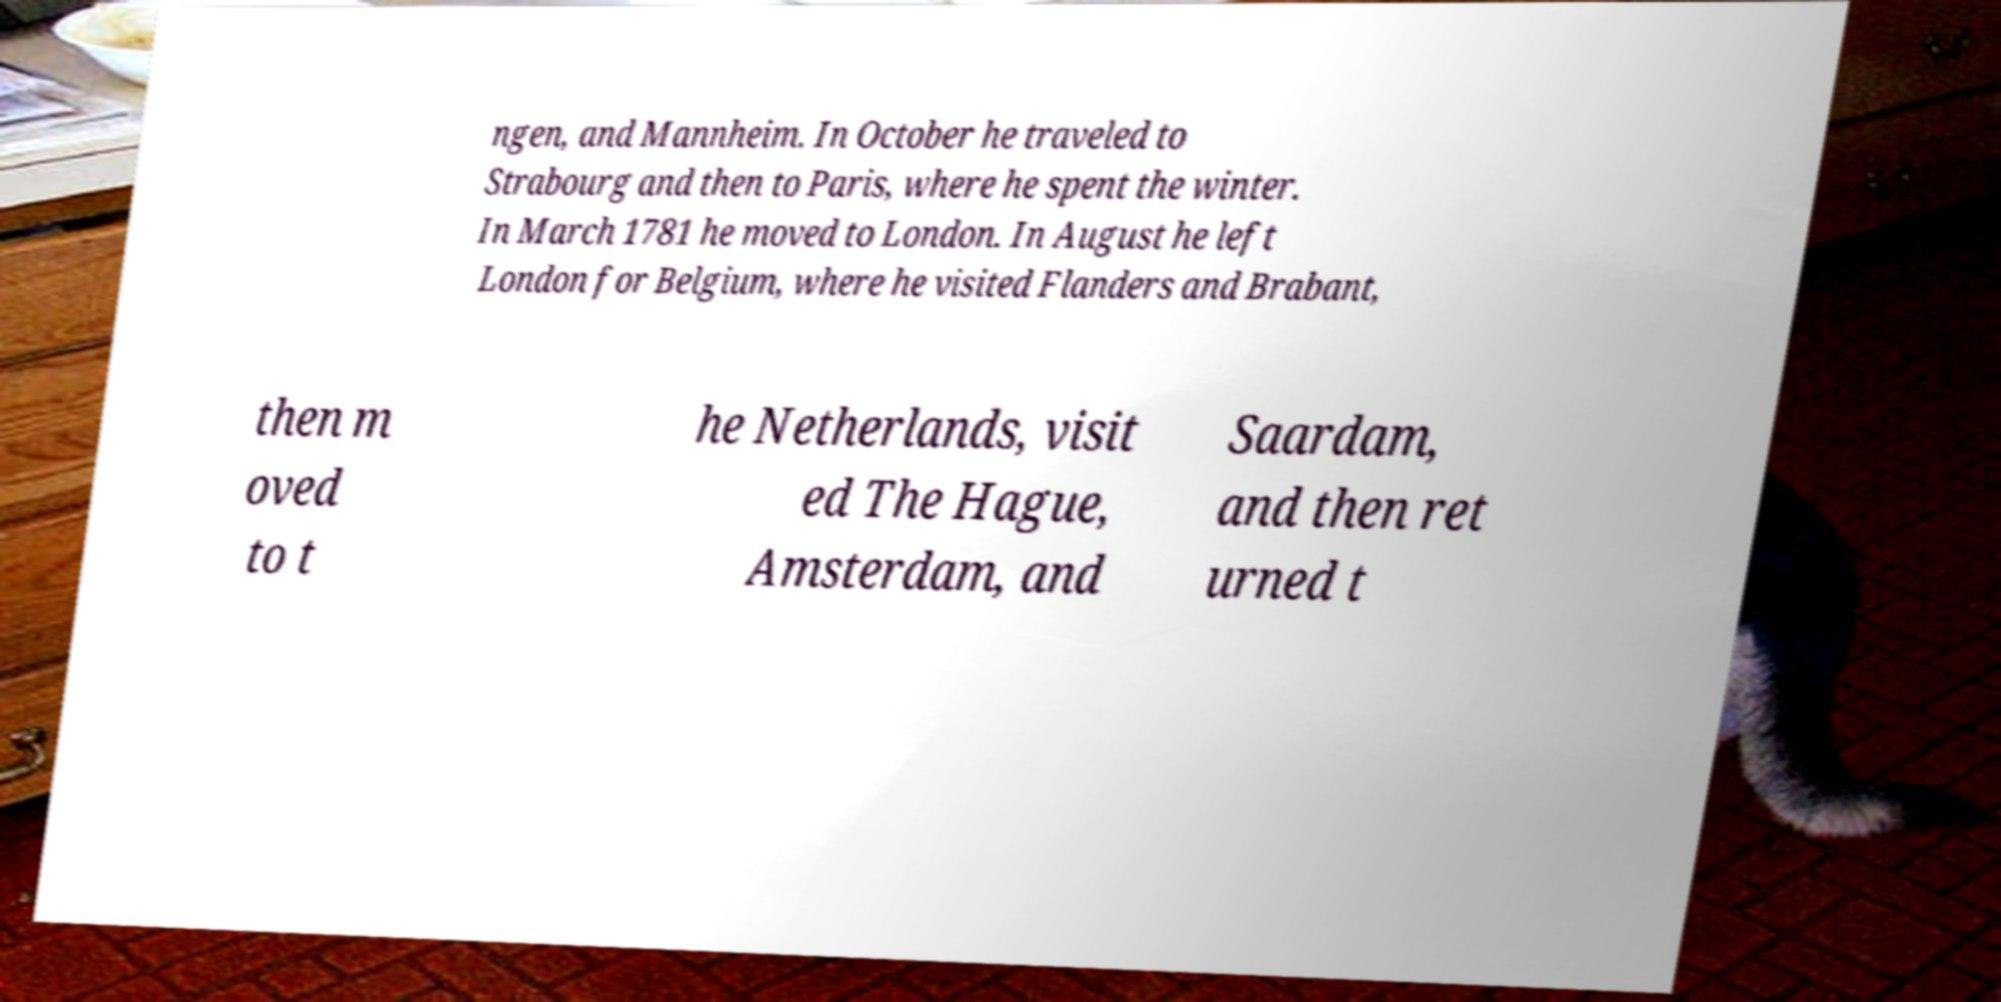For documentation purposes, I need the text within this image transcribed. Could you provide that? ngen, and Mannheim. In October he traveled to Strabourg and then to Paris, where he spent the winter. In March 1781 he moved to London. In August he left London for Belgium, where he visited Flanders and Brabant, then m oved to t he Netherlands, visit ed The Hague, Amsterdam, and Saardam, and then ret urned t 